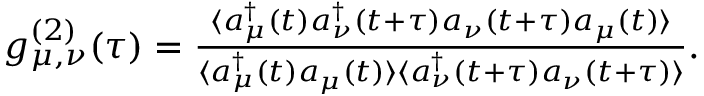<formula> <loc_0><loc_0><loc_500><loc_500>\begin{array} { r } { g _ { \mu , \nu } ^ { ( 2 ) } ( \tau ) = \frac { \langle { a _ { \mu } ^ { \dag } ( t ) } { a _ { \nu } ^ { \dag } ( t + \tau ) } { a _ { \nu } ( t + \tau ) } { a _ { \mu } ( t ) } \rangle } { \langle { a _ { \mu } ^ { \dag } ( t ) } { a _ { \mu } ( t ) } \rangle \langle { a _ { \nu } ^ { \dag } ( t + \tau ) } { a _ { \nu } ( t + \tau ) } \rangle } . } \end{array}</formula> 